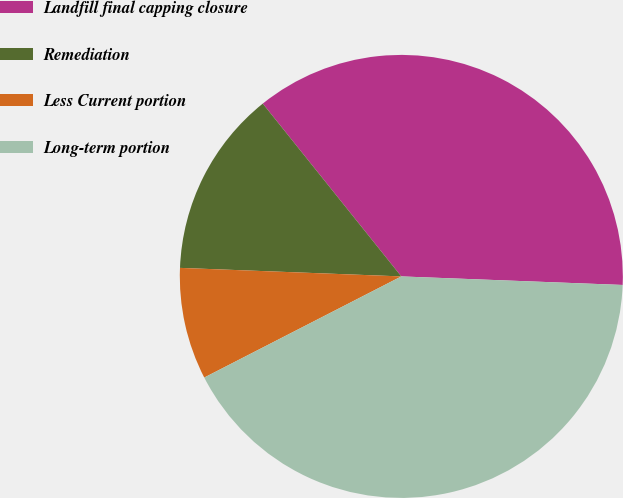Convert chart to OTSL. <chart><loc_0><loc_0><loc_500><loc_500><pie_chart><fcel>Landfill final capping closure<fcel>Remediation<fcel>Less Current portion<fcel>Long-term portion<nl><fcel>36.37%<fcel>13.63%<fcel>8.16%<fcel>41.84%<nl></chart> 